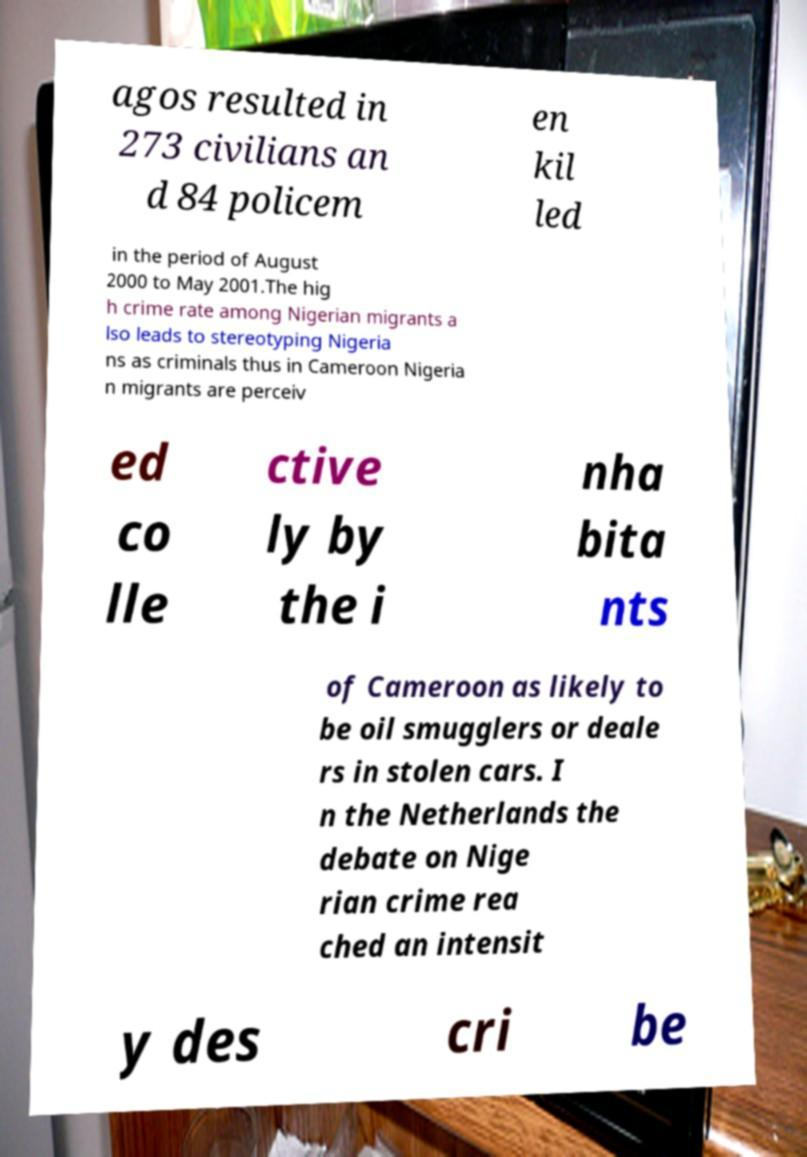Could you extract and type out the text from this image? agos resulted in 273 civilians an d 84 policem en kil led in the period of August 2000 to May 2001.The hig h crime rate among Nigerian migrants a lso leads to stereotyping Nigeria ns as criminals thus in Cameroon Nigeria n migrants are perceiv ed co lle ctive ly by the i nha bita nts of Cameroon as likely to be oil smugglers or deale rs in stolen cars. I n the Netherlands the debate on Nige rian crime rea ched an intensit y des cri be 